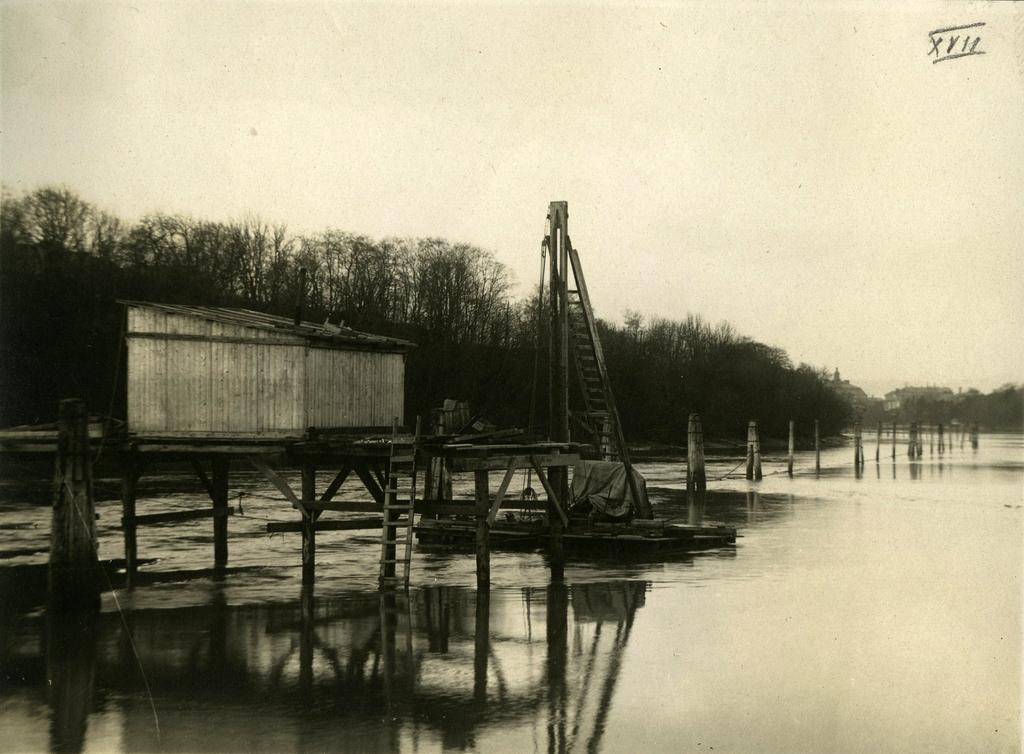What is the color scheme of the image? The image is black and white. What type of vegetation can be seen in the image? There are trees in the image. What type of structure is present in the image? There is a shed in the image. What object is used for climbing in the image? There is a wooden ladder in the image. What natural element is visible in the image? There is water visible in the image. What type of barrier is present in the image? There is a wooden fence in the image. What part of the natural environment is visible in the image? The sky is visible in the image. What type of calendar is hanging on the wooden fence in the image? There is no calendar present in the image; it is a black and white image featuring trees, a shed, a wooden ladder, water, and a wooden fence. 